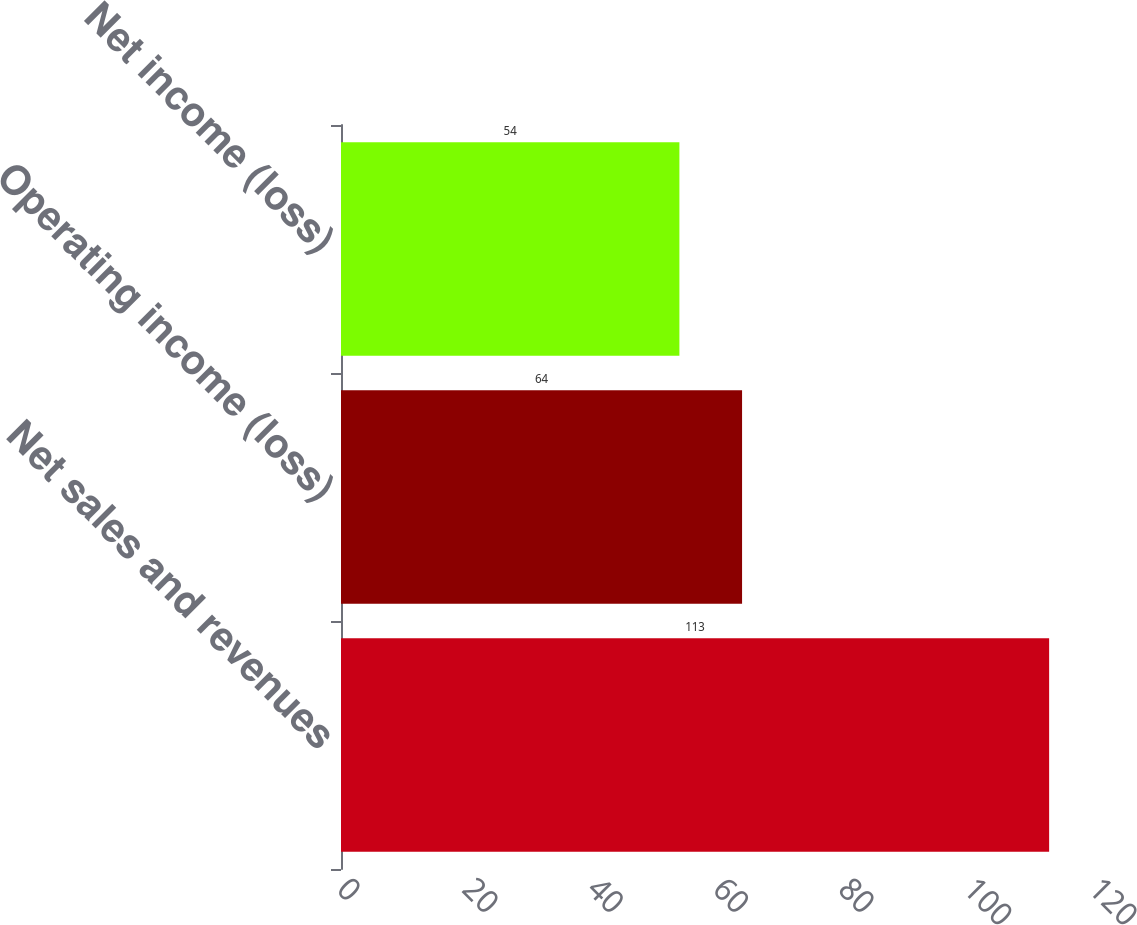<chart> <loc_0><loc_0><loc_500><loc_500><bar_chart><fcel>Net sales and revenues<fcel>Operating income (loss)<fcel>Net income (loss)<nl><fcel>113<fcel>64<fcel>54<nl></chart> 